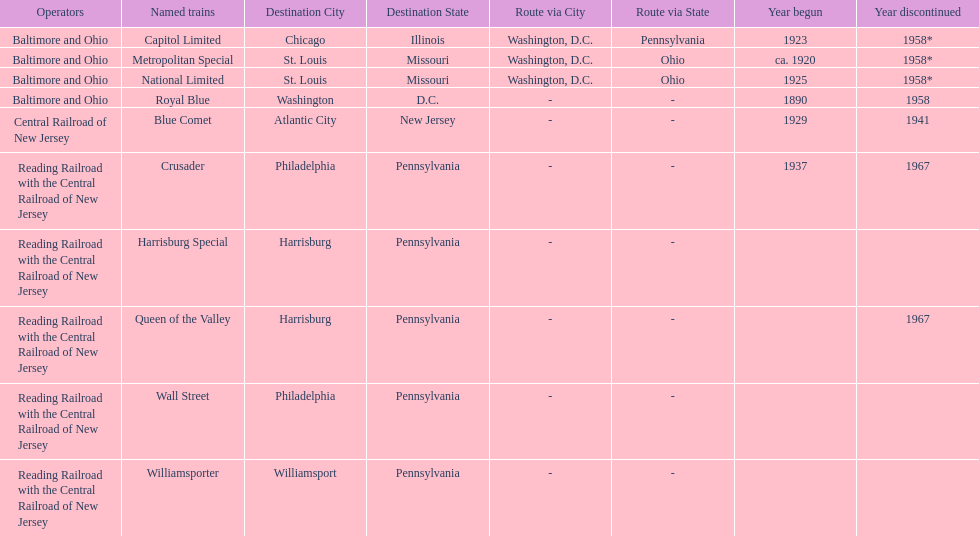Parse the table in full. {'header': ['Operators', 'Named trains', 'Destination City', 'Destination State', 'Route via City', 'Route via State', 'Year begun', 'Year discontinued'], 'rows': [['Baltimore and Ohio', 'Capitol Limited', 'Chicago', 'Illinois', 'Washington, D.C.', 'Pennsylvania', '1923', '1958*'], ['Baltimore and Ohio', 'Metropolitan Special', 'St. Louis', 'Missouri', 'Washington, D.C.', 'Ohio', 'ca. 1920', '1958*'], ['Baltimore and Ohio', 'National Limited', 'St. Louis', 'Missouri', 'Washington, D.C.', 'Ohio', '1925', '1958*'], ['Baltimore and Ohio', 'Royal Blue', 'Washington', 'D.C.', '-', '-', '1890', '1958'], ['Central Railroad of New Jersey', 'Blue Comet', 'Atlantic City', 'New Jersey', '-', '-', '1929', '1941'], ['Reading Railroad with the Central Railroad of New Jersey', 'Crusader', 'Philadelphia', 'Pennsylvania', '-', '-', '1937', '1967'], ['Reading Railroad with the Central Railroad of New Jersey', 'Harrisburg Special', 'Harrisburg', 'Pennsylvania', '-', '-', '', ''], ['Reading Railroad with the Central Railroad of New Jersey', 'Queen of the Valley', 'Harrisburg', 'Pennsylvania', '-', '-', '', '1967'], ['Reading Railroad with the Central Railroad of New Jersey', 'Wall Street', 'Philadelphia', 'Pennsylvania', '-', '-', '', ''], ['Reading Railroad with the Central Railroad of New Jersey', 'Williamsporter', 'Williamsport', 'Pennsylvania', '-', '-', '', '']]} How many trains were discontinued in 1958? 4. 